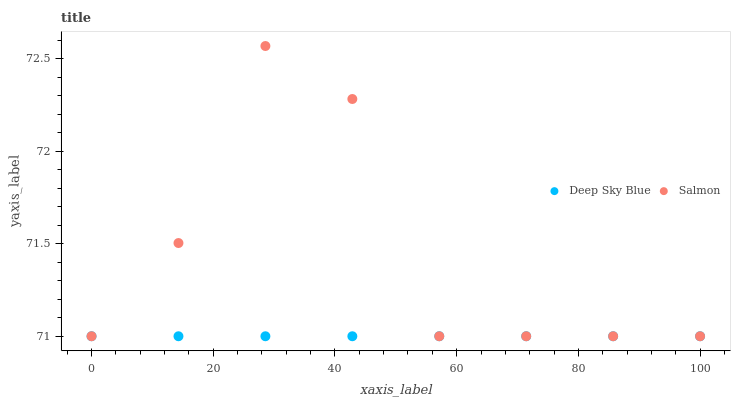Does Deep Sky Blue have the minimum area under the curve?
Answer yes or no. Yes. Does Salmon have the maximum area under the curve?
Answer yes or no. Yes. Does Deep Sky Blue have the maximum area under the curve?
Answer yes or no. No. Is Deep Sky Blue the smoothest?
Answer yes or no. Yes. Is Salmon the roughest?
Answer yes or no. Yes. Is Deep Sky Blue the roughest?
Answer yes or no. No. Does Salmon have the lowest value?
Answer yes or no. Yes. Does Salmon have the highest value?
Answer yes or no. Yes. Does Deep Sky Blue have the highest value?
Answer yes or no. No. Does Deep Sky Blue intersect Salmon?
Answer yes or no. Yes. Is Deep Sky Blue less than Salmon?
Answer yes or no. No. Is Deep Sky Blue greater than Salmon?
Answer yes or no. No. 